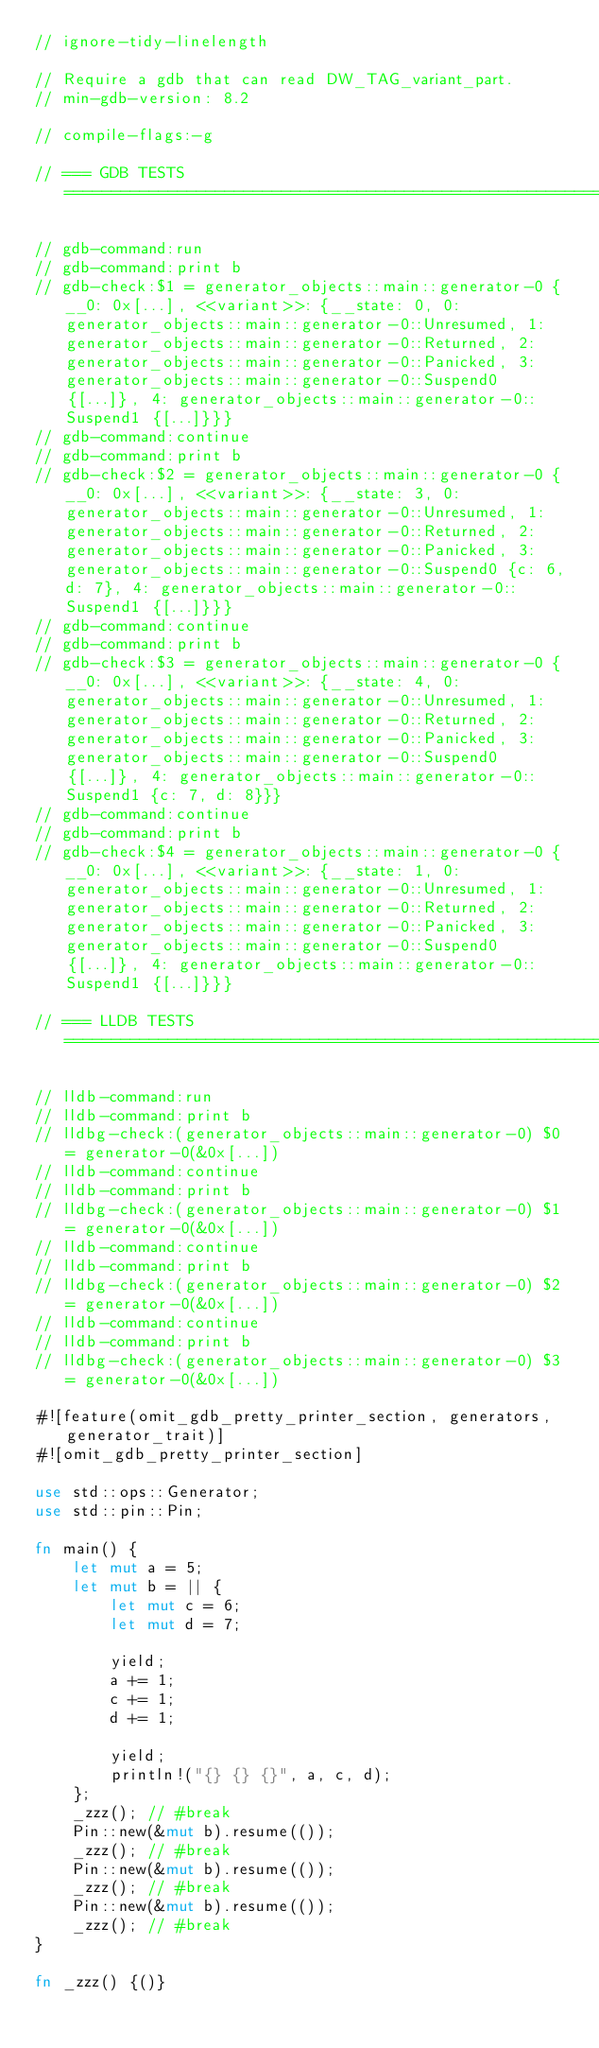<code> <loc_0><loc_0><loc_500><loc_500><_Rust_>// ignore-tidy-linelength

// Require a gdb that can read DW_TAG_variant_part.
// min-gdb-version: 8.2

// compile-flags:-g

// === GDB TESTS ===================================================================================

// gdb-command:run
// gdb-command:print b
// gdb-check:$1 = generator_objects::main::generator-0 {__0: 0x[...], <<variant>>: {__state: 0, 0: generator_objects::main::generator-0::Unresumed, 1: generator_objects::main::generator-0::Returned, 2: generator_objects::main::generator-0::Panicked, 3: generator_objects::main::generator-0::Suspend0 {[...]}, 4: generator_objects::main::generator-0::Suspend1 {[...]}}}
// gdb-command:continue
// gdb-command:print b
// gdb-check:$2 = generator_objects::main::generator-0 {__0: 0x[...], <<variant>>: {__state: 3, 0: generator_objects::main::generator-0::Unresumed, 1: generator_objects::main::generator-0::Returned, 2: generator_objects::main::generator-0::Panicked, 3: generator_objects::main::generator-0::Suspend0 {c: 6, d: 7}, 4: generator_objects::main::generator-0::Suspend1 {[...]}}}
// gdb-command:continue
// gdb-command:print b
// gdb-check:$3 = generator_objects::main::generator-0 {__0: 0x[...], <<variant>>: {__state: 4, 0: generator_objects::main::generator-0::Unresumed, 1: generator_objects::main::generator-0::Returned, 2: generator_objects::main::generator-0::Panicked, 3: generator_objects::main::generator-0::Suspend0 {[...]}, 4: generator_objects::main::generator-0::Suspend1 {c: 7, d: 8}}}
// gdb-command:continue
// gdb-command:print b
// gdb-check:$4 = generator_objects::main::generator-0 {__0: 0x[...], <<variant>>: {__state: 1, 0: generator_objects::main::generator-0::Unresumed, 1: generator_objects::main::generator-0::Returned, 2: generator_objects::main::generator-0::Panicked, 3: generator_objects::main::generator-0::Suspend0 {[...]}, 4: generator_objects::main::generator-0::Suspend1 {[...]}}}

// === LLDB TESTS ==================================================================================

// lldb-command:run
// lldb-command:print b
// lldbg-check:(generator_objects::main::generator-0) $0 = generator-0(&0x[...])
// lldb-command:continue
// lldb-command:print b
// lldbg-check:(generator_objects::main::generator-0) $1 = generator-0(&0x[...])
// lldb-command:continue
// lldb-command:print b
// lldbg-check:(generator_objects::main::generator-0) $2 = generator-0(&0x[...])
// lldb-command:continue
// lldb-command:print b
// lldbg-check:(generator_objects::main::generator-0) $3 = generator-0(&0x[...])

#![feature(omit_gdb_pretty_printer_section, generators, generator_trait)]
#![omit_gdb_pretty_printer_section]

use std::ops::Generator;
use std::pin::Pin;

fn main() {
    let mut a = 5;
    let mut b = || {
        let mut c = 6;
        let mut d = 7;

        yield;
        a += 1;
        c += 1;
        d += 1;

        yield;
        println!("{} {} {}", a, c, d);
    };
    _zzz(); // #break
    Pin::new(&mut b).resume(());
    _zzz(); // #break
    Pin::new(&mut b).resume(());
    _zzz(); // #break
    Pin::new(&mut b).resume(());
    _zzz(); // #break
}

fn _zzz() {()}
</code> 